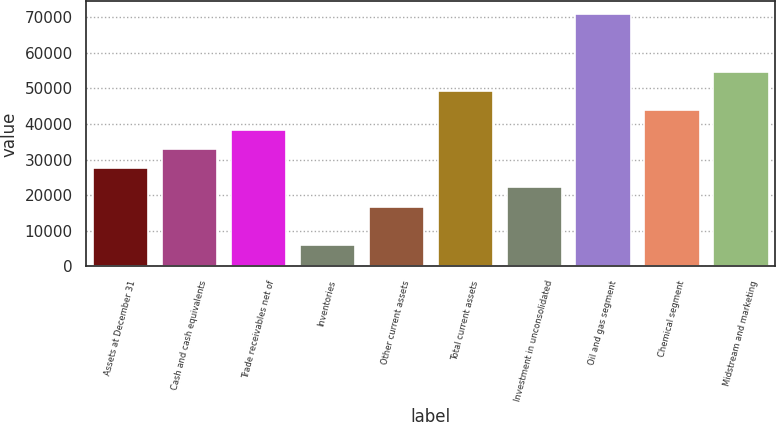Convert chart. <chart><loc_0><loc_0><loc_500><loc_500><bar_chart><fcel>Assets at December 31<fcel>Cash and cash equivalents<fcel>Trade receivables net of<fcel>Inventories<fcel>Other current assets<fcel>Total current assets<fcel>Investment in unconsolidated<fcel>Oil and gas segment<fcel>Chemical segment<fcel>Midstream and marketing<nl><fcel>27573.5<fcel>32993.4<fcel>38413.3<fcel>5893.9<fcel>16733.7<fcel>49253.1<fcel>22153.6<fcel>70932.7<fcel>43833.2<fcel>54673<nl></chart> 